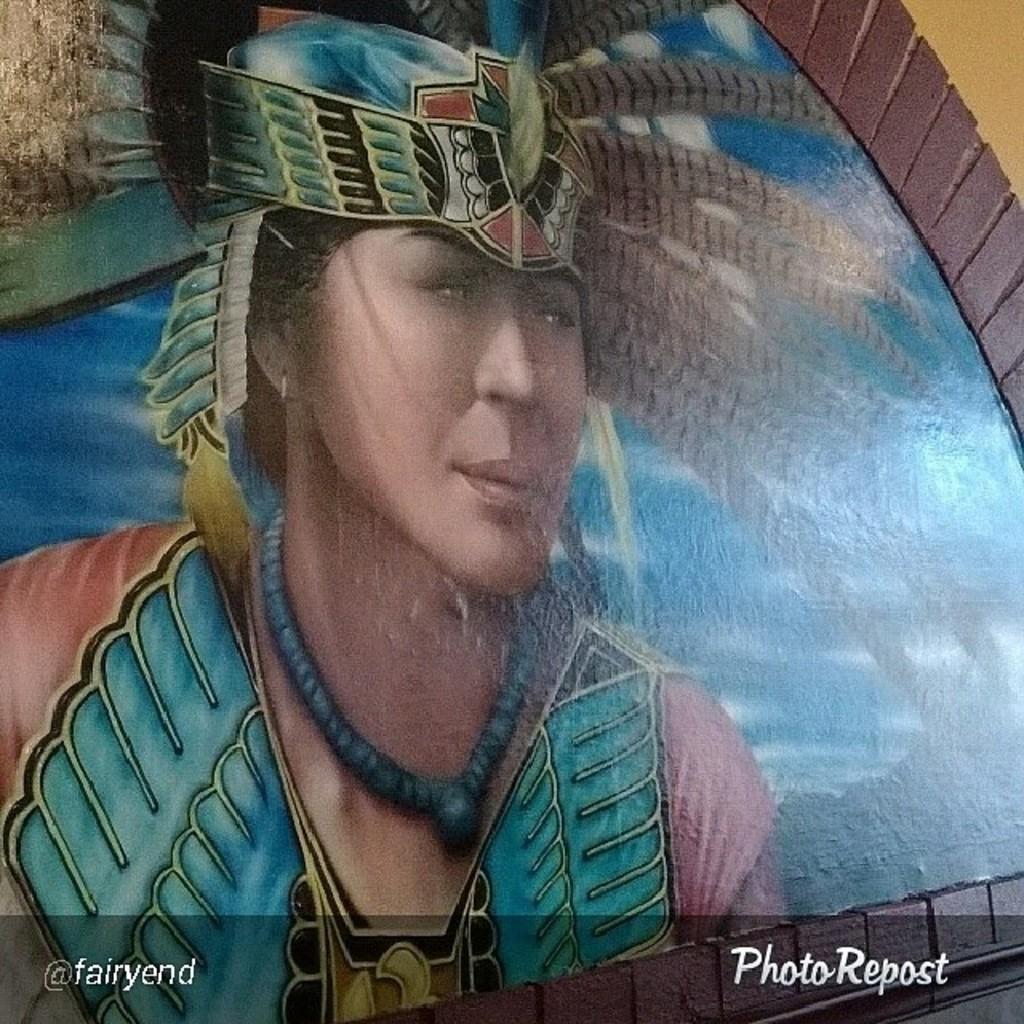In one or two sentences, can you explain what this image depicts? In this image I can see the painting to the wall. In the painting I can see the person wearing the blue and Brown color dress and the person is with the crown. In the background I can see the clouds and the sky. The wall is in yellow color. 